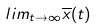Convert formula to latex. <formula><loc_0><loc_0><loc_500><loc_500>l i m _ { t \rightarrow \infty } \overline { x } ( t )</formula> 